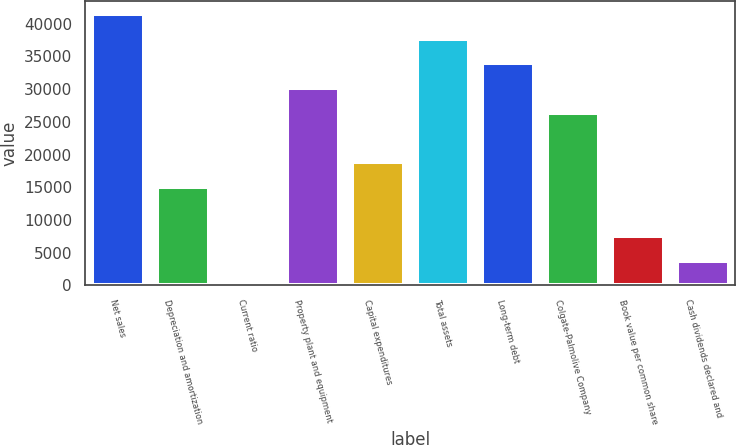Convert chart to OTSL. <chart><loc_0><loc_0><loc_500><loc_500><bar_chart><fcel>Net sales<fcel>Depreciation and amortization<fcel>Current ratio<fcel>Property plant and equipment<fcel>Capital expenditures<fcel>Total assets<fcel>Long-term debt<fcel>Colgate-Palmolive Company<fcel>Book value per common share<fcel>Cash dividends declared and<nl><fcel>41469.9<fcel>15080.7<fcel>1.2<fcel>30160.2<fcel>18850.6<fcel>37700<fcel>33930.1<fcel>26390.4<fcel>7540.96<fcel>3771.08<nl></chart> 